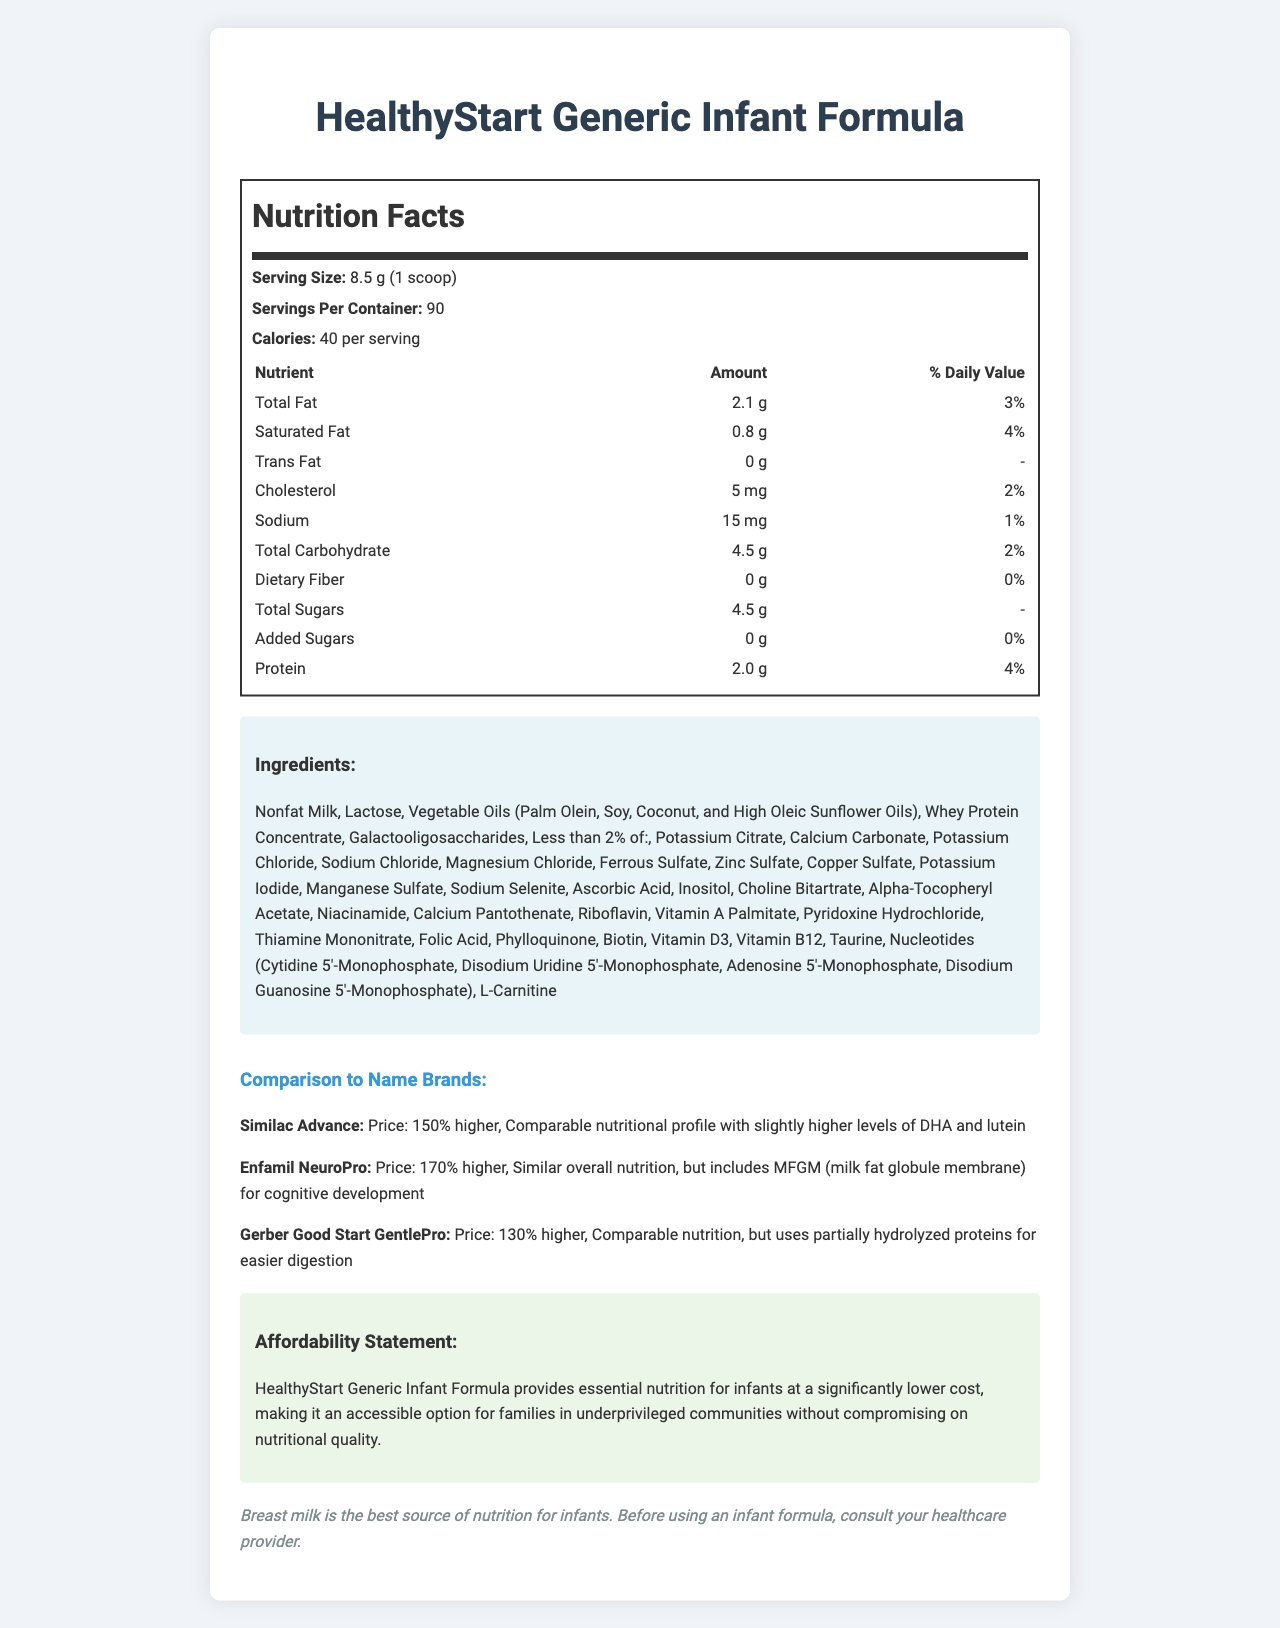who is the manufacturer of the infant formula? The document does not provide information about the manufacturer, only the product name "HealthyStart Generic Infant Formula."
Answer: Cannot be determined what is the serving size of the HealthyStart Generic Infant Formula? The serving size is specified as 8.5 grams (1 scoop) in the nutrition facts section.
Answer: 8.5 g (1 scoop) how many calories are there per serving in the HealthyStart Generic Infant Formula? The document states that there are 40 calories per serving.
Answer: 40 calories which vitamin has the highest daily value percentage in the HealthyStart Generic Infant Formula? Niacin has a daily value percentage of 25%, which is the highest among all the listed vitamins and minerals.
Answer: Niacin what is the amount of protein in one serving of the HealthyStart Generic Infant Formula? The nutrition label lists 2.0 grams of protein per serving.
Answer: 2.0 g which ingredient is listed first in the ingredients section? A. Lactose B. Nonfat Milk C. Vegetable Oils D. Whey Protein Concentrate The first ingredient listed is Nonfat Milk.
Answer: B which name-brand formula has the highest price compared to HealthyStart Generic Infant Formula? A. Similac Advance B. Enfamil NeuroPro C. Gerber Good Start GentlePro Enfamil NeuroPro is 170% higher in price, making it the most expensive compared to the HealthyStart Generic Infant Formula.
Answer: B is the HealthyStart Generic Infant Formula an affordable option for underprivileged communities? The affordability statement mentions that it provides essential nutrition at a significantly lower cost, making it accessible for underprivileged communities.
Answer: Yes does the HealthyStart Generic Infant Formula contain any dietary fiber? The document shows that dietary fiber is 0 g per serving.
Answer: No summarize the main idea of the document. The document provides a comprehensive overview of the nutritional profile of the HealthyStart Generic Infant Formula, its affordability, and how it compares with more expensive name-brand alternatives, emphasizing its cost-effectiveness and essential nutritional benefits.
Answer: HealthyStart Generic Infant Formula is a cost-effective alternative to name-brand infant formulas. It provides essential nutrition, like vitamins and minerals, comparable to more expensive options, and is designed to be an accessible choice for families in underprivileged communities. The document includes detailed nutrition facts, ingredients, comparative analysis with other brands, an affordability statement, and a disclaimer about infant nutrition. how much Vitamin C is in one serving of the HealthyStart Generic Infant Formula? According to the nutrition facts, one serving contains 8 mg of Vitamin C.
Answer: 8 mg what is the cost comparison between HealthyStart Generic Infant Formula and Similac Advance? The document states that Similac Advance is 150% higher in price compared to HealthyStart Generic Infant Formula.
Answer: 150% higher which nutrient has the lowest daily value percentage in the HealthyStart Generic Infant Formula? Manganese has the lowest daily value percentage at 1%.
Answer: Manganese is there any information about DHA or lutein in HealthyStart Generic Infant Formula? The document does not provide information about the presence of DHA or lutein in HealthyStart Generic Infant Formula, although it mentions these nutrients in the comparison with Similac Advance.
Answer: No describe the ingredients used in the HealthyStart Generic Infant Formula. The document lists a variety of ingredients used in the formula, emphasizing milk-based components and essential nutrients with detailed mentions of minerals, vitamins, and other beneficial compounds that contribute to infant nutrition.
Answer: The ingredients include Nonfat Milk, Lactose, Vegetable Oils (Palm Olein, Soy, Coconut, and High Oleic Sunflower Oils), Whey Protein Concentrate, and Galactooligosaccharides. The formula also contains less than 2% of various minerals, vitamins, and other nutrients such as Potassium Citrate, Calcium Carbonate, and Taurine. 